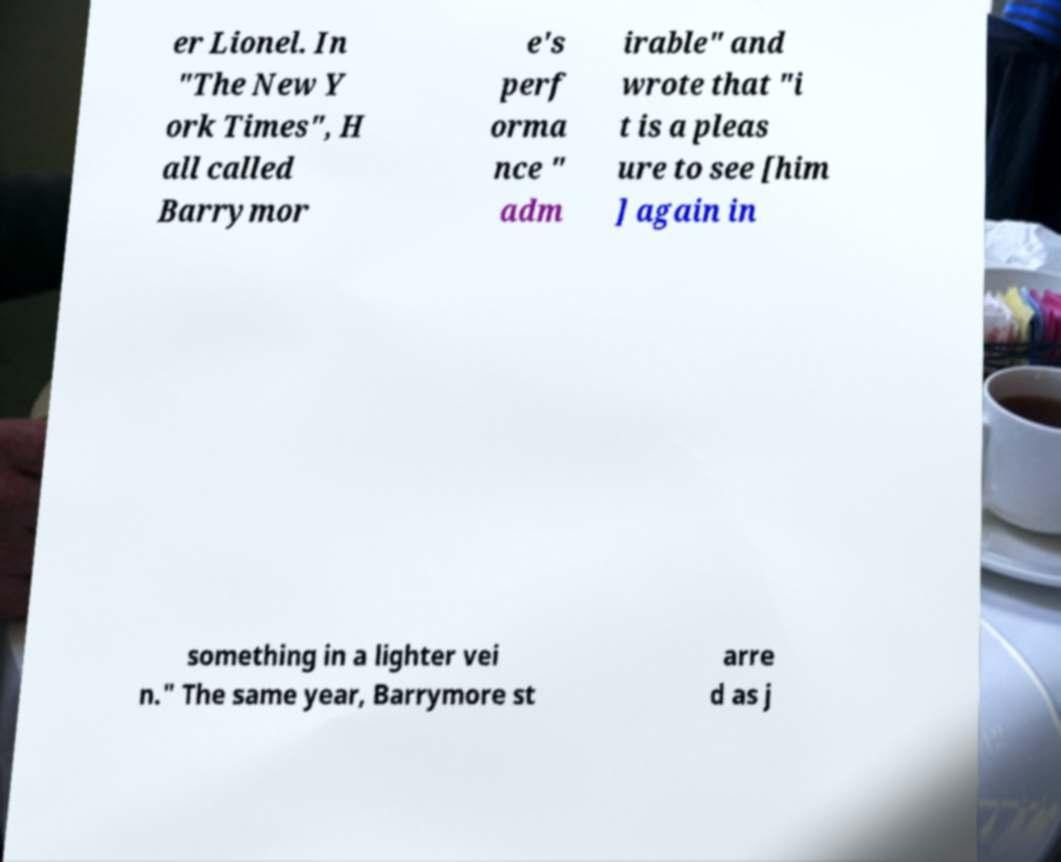Can you read and provide the text displayed in the image?This photo seems to have some interesting text. Can you extract and type it out for me? er Lionel. In "The New Y ork Times", H all called Barrymor e's perf orma nce " adm irable" and wrote that "i t is a pleas ure to see [him ] again in something in a lighter vei n." The same year, Barrymore st arre d as j 